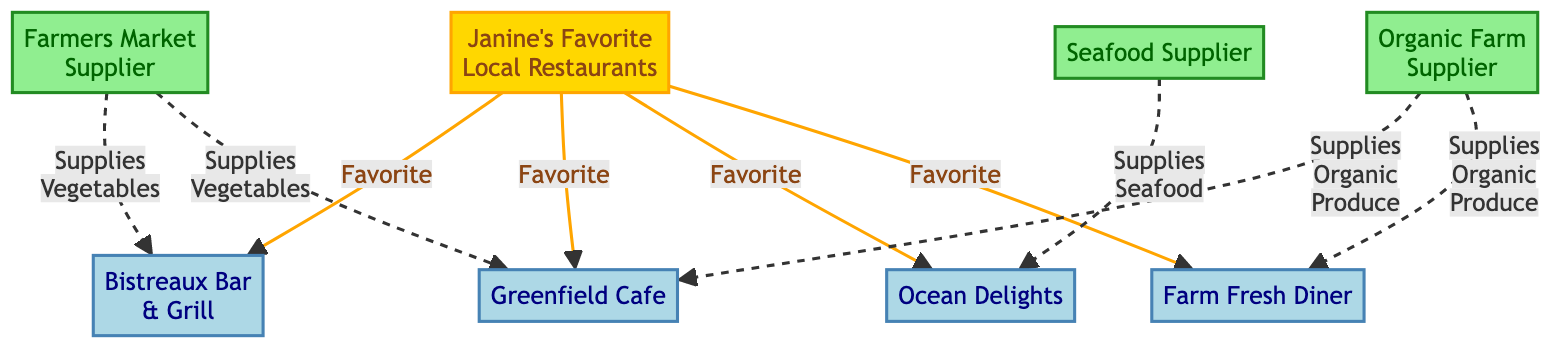What are Janine's favorite local restaurants? The diagram shows four restaurants connected to "Janine's Favorite Local Restaurants": Bistreaux Bar & Grill, Greenfield Cafe, Ocean Delights, and Farm Fresh Diner.
Answer: Bistreaux Bar & Grill, Greenfield Cafe, Ocean Delights, Farm Fresh Diner Which supplier supplies seafood? The diagram indicates that the "Seafood Supplier" provides seafood to "Ocean Delights." There is a direct connection between these two nodes.
Answer: Seafood Supplier How many restaurants are listed in the diagram? The diagram lists four restaurants: Bistreaux Bar & Grill, Greenfield Cafe, Ocean Delights, and Farm Fresh Diner. Counting these nodes gives us the total number.
Answer: 4 What type of produce does the Organic Farm Supplier provide? The "Organic Farm Supplier" supplies "Organic Produce" to both Greenfield Cafe and Farm Fresh Diner, as indicated by the connections in the diagram.
Answer: Organic Produce Which restaurant receives supplies from both the Farmers Market and Organic Farm Supplier? The diagram shows that "Greenfield Cafe" receives supplies from both the "Farmers Market" for vegetables and the "Organic Farm Supplier" for organic produce. These connections indicate the involvement of both suppliers.
Answer: Greenfield Cafe How many suppliers are shown in the diagram? The diagram lists three suppliers: Farmers Market, Seafood Supplier, and Organic Farm Supplier. Counting these nodes reveals the total number of suppliers.
Answer: 3 What type of supplies does the Farmers Market provide? The "Farmers Market" is connected to both "Bistreaux Bar & Grill" and "Greenfield Cafe" with the label "Supplies Vegetables," indicating that it provides vegetables to these restaurants.
Answer: Vegetables Which restaurant is exclusively supplied by the Seafood Supplier? The connection shows that only "Ocean Delights" is supplied seafood by the "Seafood Supplier," indicating exclusivity in this relationship.
Answer: Ocean Delights 